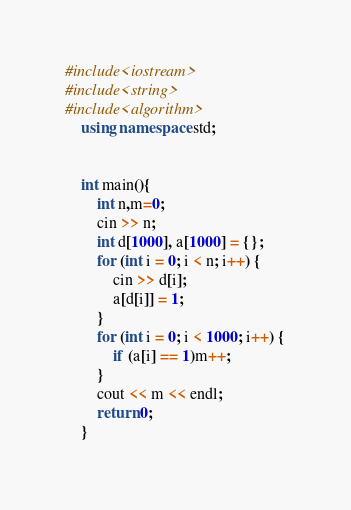<code> <loc_0><loc_0><loc_500><loc_500><_C++_>#include<iostream>
#include<string>
#include<algorithm>
    using namespace std;


    int main(){
        int n,m=0;
        cin >> n;
        int d[1000], a[1000] = {};
        for (int i = 0; i < n; i++) {
            cin >> d[i];
            a[d[i]] = 1;
        }
        for (int i = 0; i < 1000; i++) {
            if (a[i] == 1)m++;
        }
        cout << m << endl;
        return 0;
    }</code> 